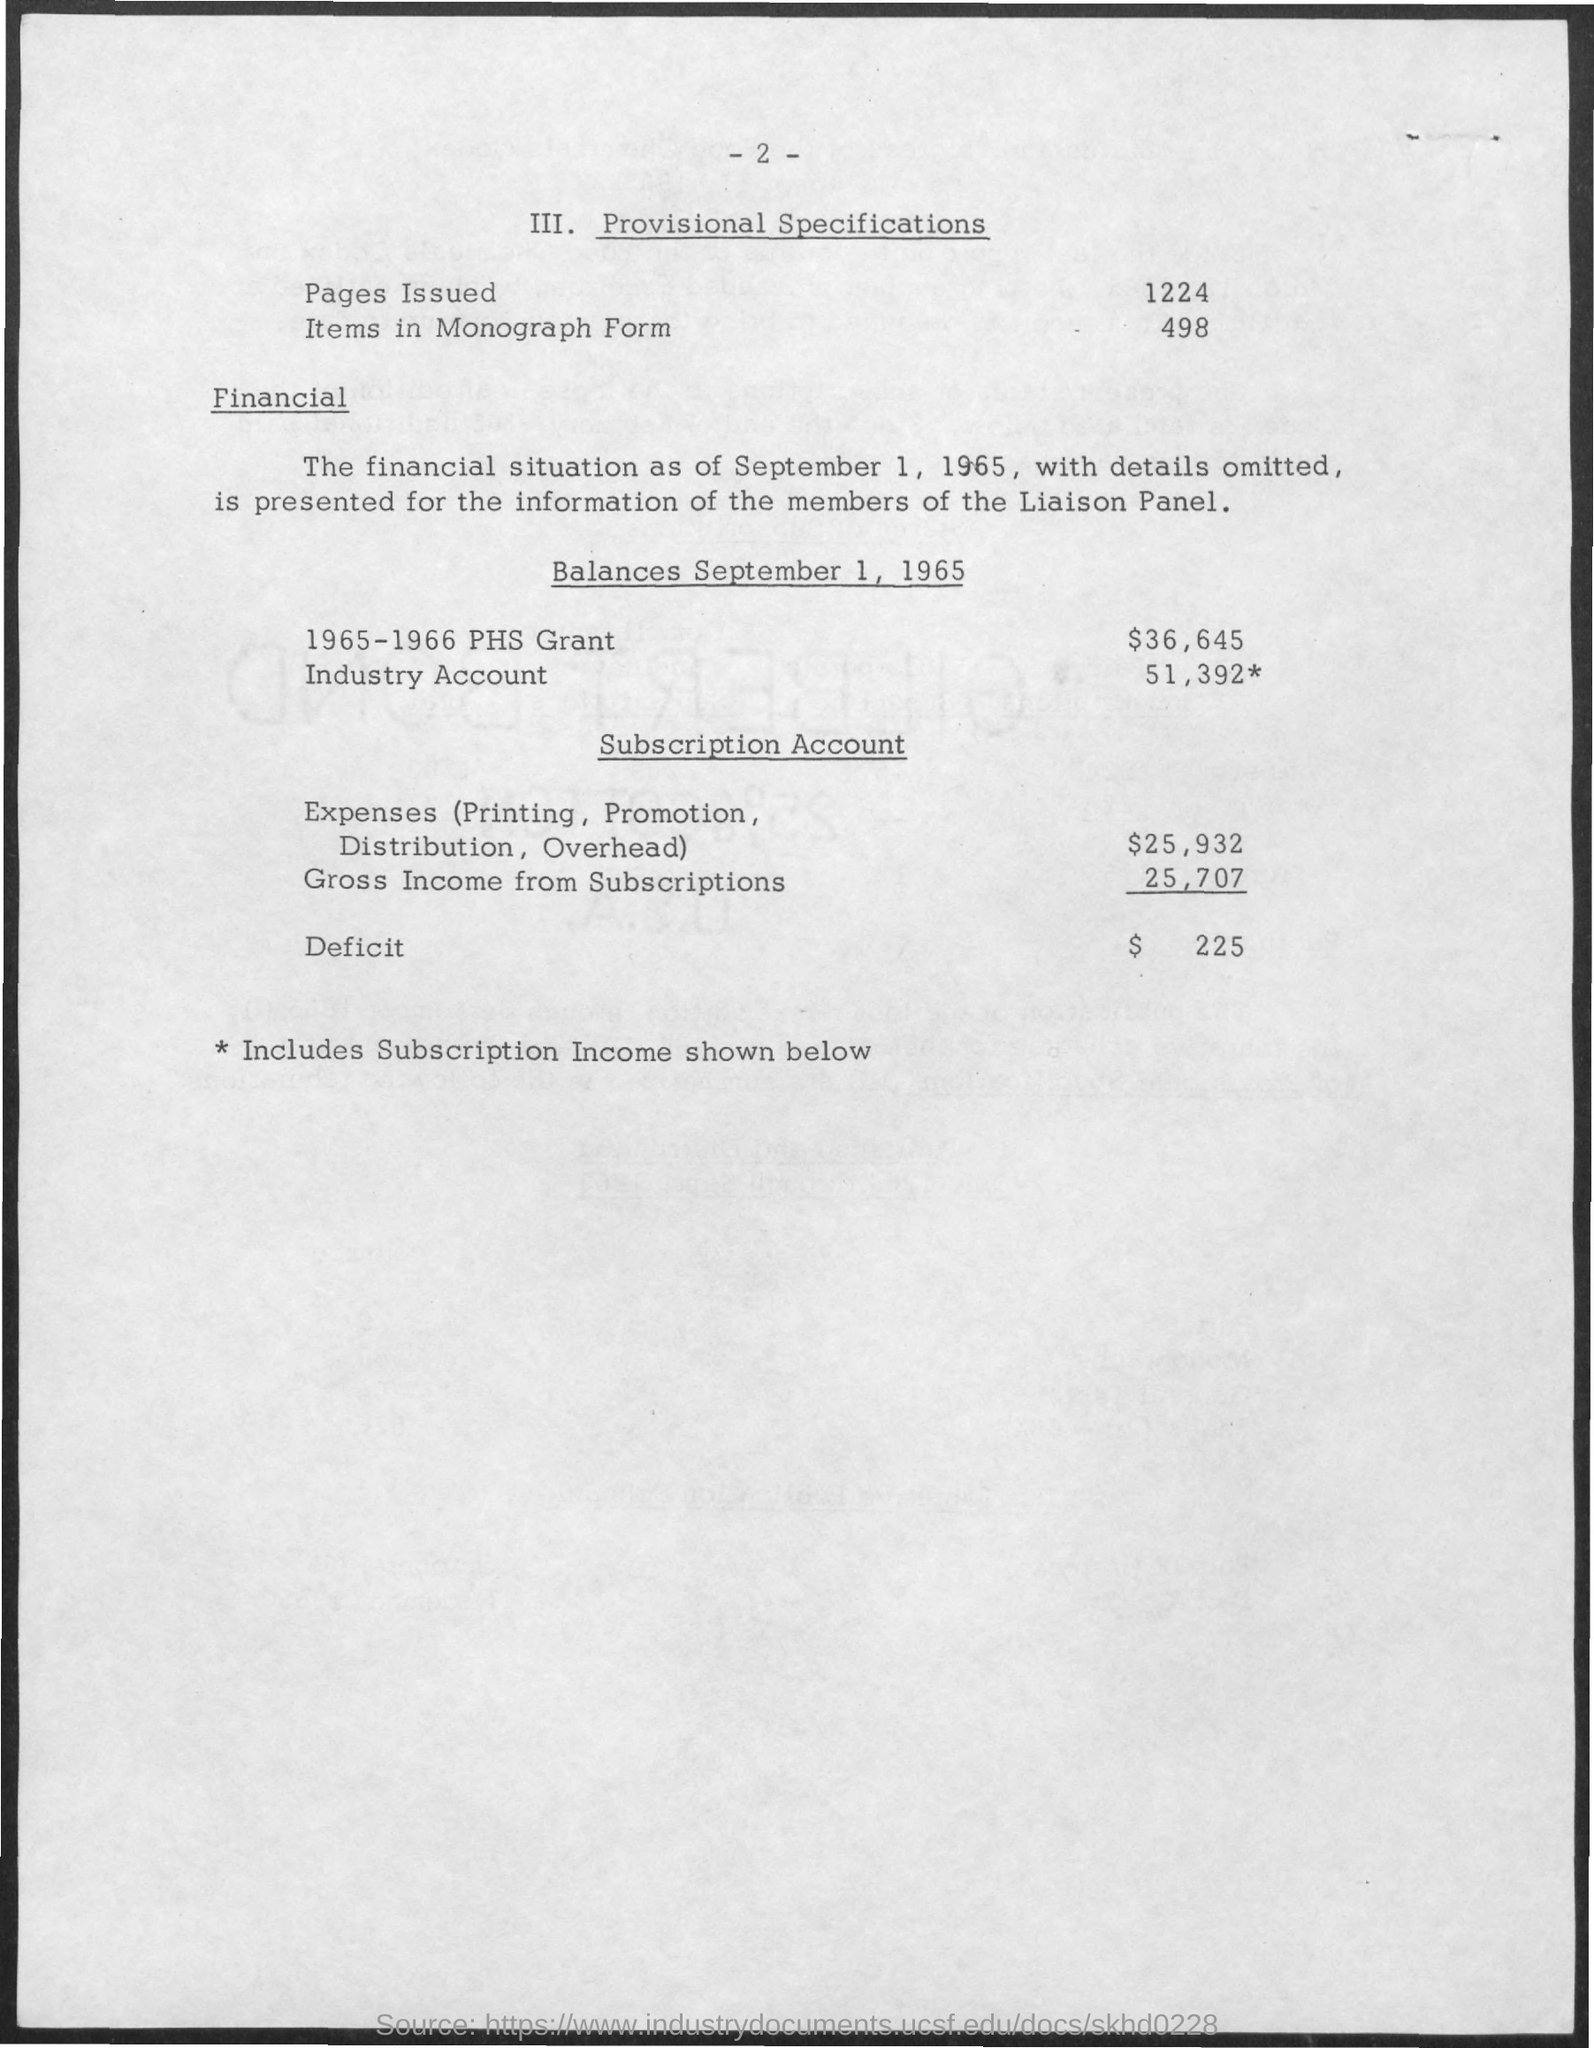What is the Title of the document?
Ensure brevity in your answer.  Provisional Specifications. What are the balances September 1, 1965 for 1965-1966 PHS Grant?
Offer a terse response. $36,645. What are the balances September 1, 1965 for Industry Account?
Provide a succinct answer. 51,392. How many pages Issued?
Your response must be concise. 1224. How many Items in Monograph Form?
Your answer should be very brief. 498. What is the Subscription Account for Expenses (Printing, Promotion, Distribution, Overhead)?
Give a very brief answer. $25,932. What is the Subscription Account for Gross Income from Subscriptions?
Your answer should be very brief. 25,707. What are the Deficit?
Offer a very short reply. $ 225. 